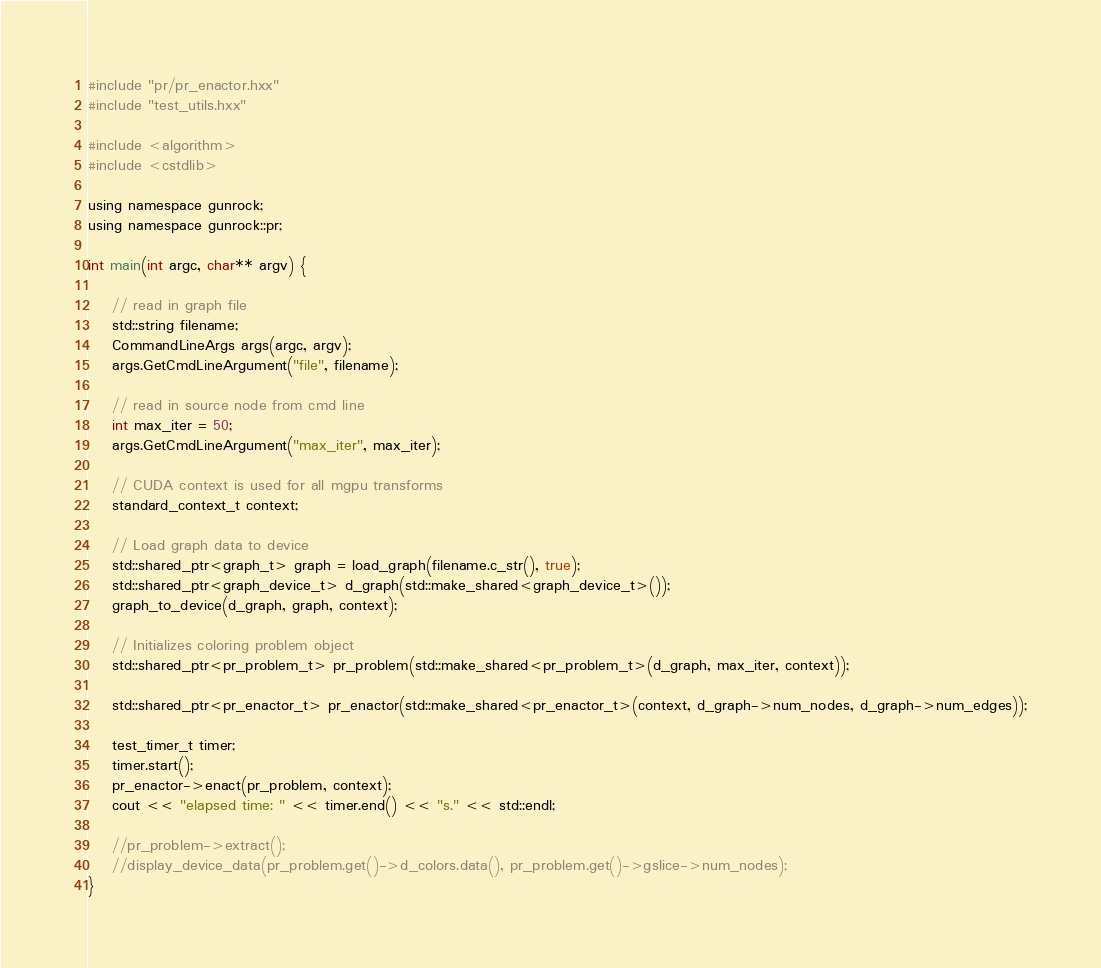Convert code to text. <code><loc_0><loc_0><loc_500><loc_500><_Cuda_>#include "pr/pr_enactor.hxx"
#include "test_utils.hxx"

#include <algorithm>
#include <cstdlib>

using namespace gunrock;
using namespace gunrock::pr;

int main(int argc, char** argv) {

    // read in graph file
    std::string filename;
    CommandLineArgs args(argc, argv);
    args.GetCmdLineArgument("file", filename);

    // read in source node from cmd line
    int max_iter = 50;
    args.GetCmdLineArgument("max_iter", max_iter);

    // CUDA context is used for all mgpu transforms
    standard_context_t context;
   
    // Load graph data to device
    std::shared_ptr<graph_t> graph = load_graph(filename.c_str(), true);
    std::shared_ptr<graph_device_t> d_graph(std::make_shared<graph_device_t>());
    graph_to_device(d_graph, graph, context);

    // Initializes coloring problem object
    std::shared_ptr<pr_problem_t> pr_problem(std::make_shared<pr_problem_t>(d_graph, max_iter, context));

    std::shared_ptr<pr_enactor_t> pr_enactor(std::make_shared<pr_enactor_t>(context, d_graph->num_nodes, d_graph->num_edges));

    test_timer_t timer;
    timer.start();
    pr_enactor->enact(pr_problem, context);
    cout << "elapsed time: " << timer.end() << "s." << std::endl;

    //pr_problem->extract();
    //display_device_data(pr_problem.get()->d_colors.data(), pr_problem.get()->gslice->num_nodes);
}



</code> 